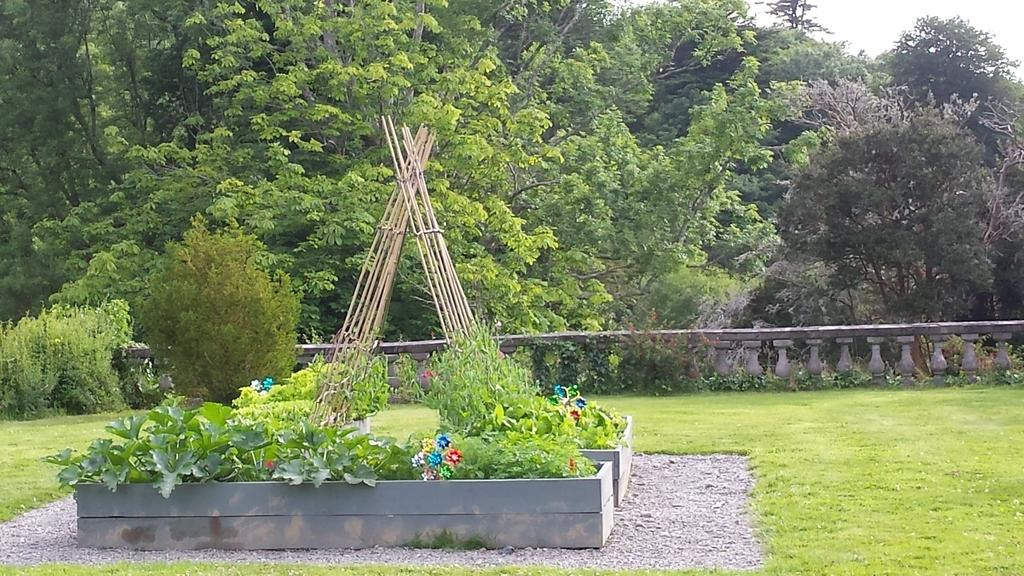What is the main object in the image? There is a box in the image. What is inside the box? The box contains plants and flowers. What else can be seen in the image besides the box? There are sticks, grass, and trees in the background of the image. What is present in the background of the image? There is a fence in the background of the image. What type of science experiment can be seen in the image? There is no science experiment present in the image; it features a box containing plants and flowers. What type of bells can be heard ringing in the image? There are no bells present in the image, and therefore no sound can be heard. 